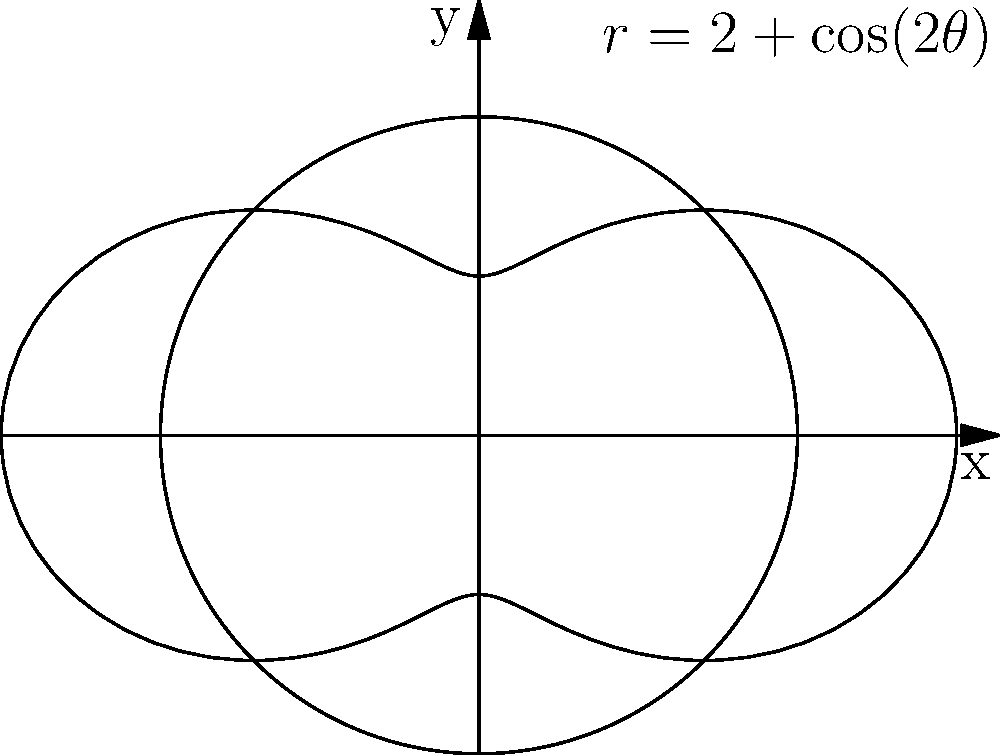An oil field is represented by the region enclosed between the circle $r=2$ and the curve $r=2+\cos(2\theta)$ in polar coordinates, as shown in the figure. Calculate the area of this oil field in square kilometers, assuming each unit on the graph represents 1 km. Round your answer to two decimal places. To find the area of the oil field, we need to calculate the area between the two curves. Let's approach this step-by-step:

1) The area between two polar curves is given by the formula:

   $$A = \frac{1}{2} \int_{0}^{2\pi} [R^2(\theta) - r^2(\theta)] d\theta$$

   where $R(\theta)$ is the outer curve and $r(\theta)$ is the inner curve.

2) In this case, $R(\theta) = 2 + \cos(2\theta)$ and $r(\theta) = 2$

3) Substituting into the formula:

   $$A = \frac{1}{2} \int_{0}^{2\pi} [(2 + \cos(2\theta))^2 - 2^2] d\theta$$

4) Expand the squared term:

   $$A = \frac{1}{2} \int_{0}^{2\pi} [4 + 4\cos(2\theta) + \cos^2(2\theta) - 4] d\theta$$

5) Simplify:

   $$A = \frac{1}{2} \int_{0}^{2\pi} [4\cos(2\theta) + \cos^2(2\theta)] d\theta$$

6) Use the identity $\cos^2(2\theta) = \frac{1}{2}(1 + \cos(4\theta))$:

   $$A = \frac{1}{2} \int_{0}^{2\pi} [4\cos(2\theta) + \frac{1}{2} + \frac{1}{2}\cos(4\theta)] d\theta$$

7) Integrate:

   $$A = \frac{1}{2} [2\sin(2\theta) + \frac{1}{2}\theta + \frac{1}{8}\sin(4\theta)]_0^{2\pi}$$

8) Evaluate the definite integral:

   $$A = \frac{1}{2} [(0 + \pi + 0) - (0 + 0 + 0)] = \frac{\pi}{2}$$

9) Therefore, the area is $\frac{\pi}{2}$ square units.

10) As each unit represents 1 km, the area in square kilometers is $\frac{\pi}{2} \approx 1.57$ km².
Answer: 1.57 km² 